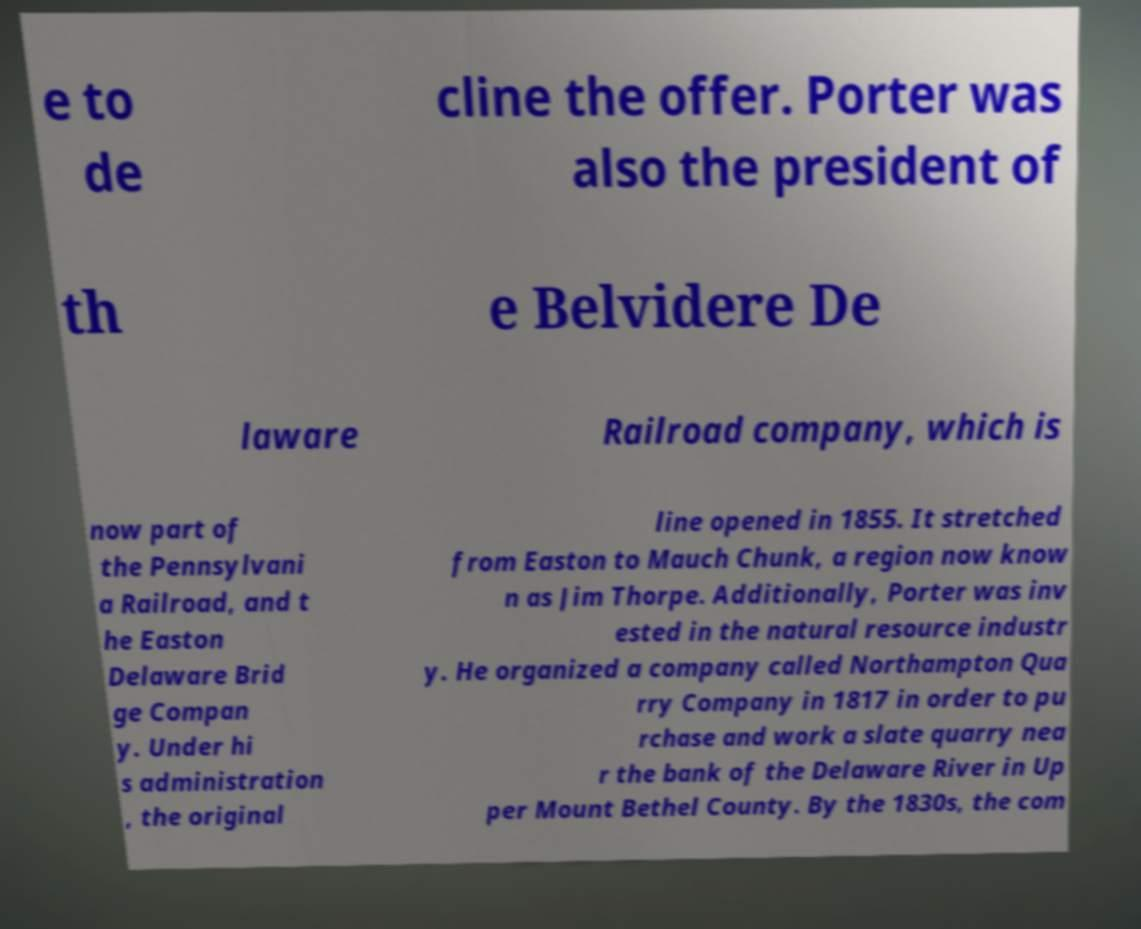Can you accurately transcribe the text from the provided image for me? e to de cline the offer. Porter was also the president of th e Belvidere De laware Railroad company, which is now part of the Pennsylvani a Railroad, and t he Easton Delaware Brid ge Compan y. Under hi s administration , the original line opened in 1855. It stretched from Easton to Mauch Chunk, a region now know n as Jim Thorpe. Additionally, Porter was inv ested in the natural resource industr y. He organized a company called Northampton Qua rry Company in 1817 in order to pu rchase and work a slate quarry nea r the bank of the Delaware River in Up per Mount Bethel County. By the 1830s, the com 